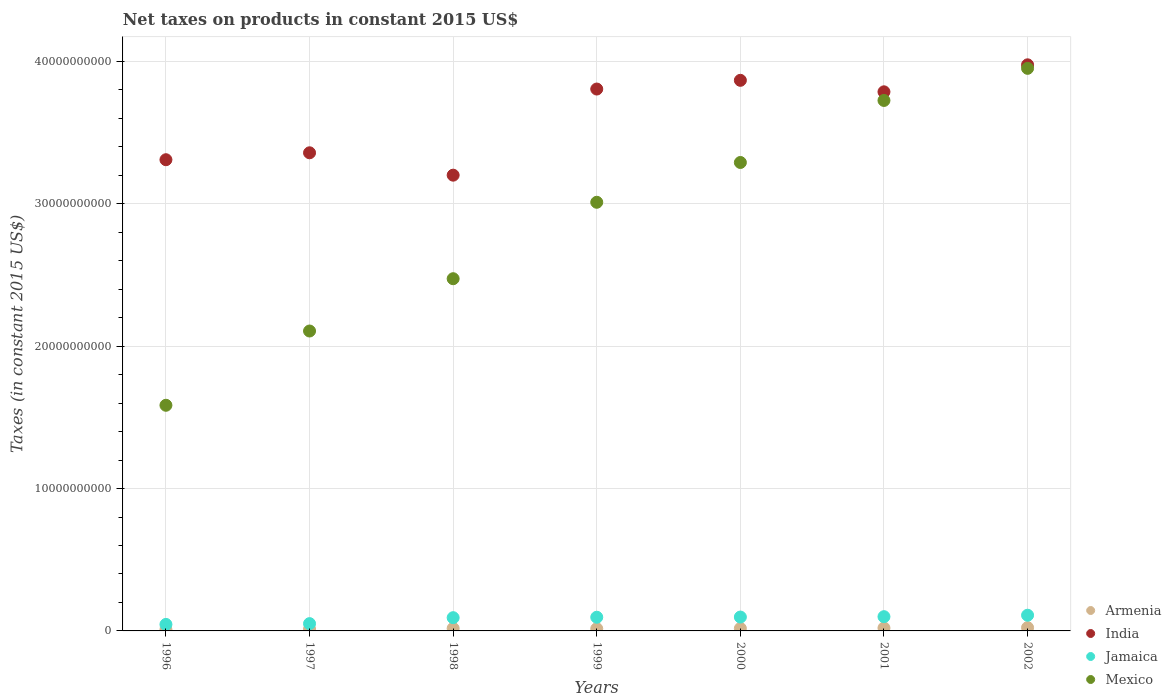What is the net taxes on products in Jamaica in 1998?
Ensure brevity in your answer.  9.30e+08. Across all years, what is the maximum net taxes on products in India?
Ensure brevity in your answer.  3.98e+1. Across all years, what is the minimum net taxes on products in Mexico?
Your response must be concise. 1.58e+1. In which year was the net taxes on products in Armenia maximum?
Provide a short and direct response. 2002. What is the total net taxes on products in Armenia in the graph?
Ensure brevity in your answer.  1.16e+09. What is the difference between the net taxes on products in India in 1997 and that in 1998?
Provide a succinct answer. 1.57e+09. What is the difference between the net taxes on products in Jamaica in 2002 and the net taxes on products in Mexico in 1997?
Make the answer very short. -2.00e+1. What is the average net taxes on products in Mexico per year?
Your response must be concise. 2.88e+1. In the year 2000, what is the difference between the net taxes on products in India and net taxes on products in Mexico?
Offer a very short reply. 5.77e+09. In how many years, is the net taxes on products in Mexico greater than 20000000000 US$?
Provide a short and direct response. 6. What is the ratio of the net taxes on products in Armenia in 1998 to that in 2002?
Make the answer very short. 0.76. Is the net taxes on products in India in 1997 less than that in 1998?
Offer a very short reply. No. Is the difference between the net taxes on products in India in 1999 and 2002 greater than the difference between the net taxes on products in Mexico in 1999 and 2002?
Offer a very short reply. Yes. What is the difference between the highest and the second highest net taxes on products in Armenia?
Ensure brevity in your answer.  2.52e+07. What is the difference between the highest and the lowest net taxes on products in Mexico?
Give a very brief answer. 2.37e+1. In how many years, is the net taxes on products in Jamaica greater than the average net taxes on products in Jamaica taken over all years?
Ensure brevity in your answer.  5. Is the sum of the net taxes on products in Jamaica in 1996 and 2002 greater than the maximum net taxes on products in Armenia across all years?
Your answer should be very brief. Yes. Is it the case that in every year, the sum of the net taxes on products in Jamaica and net taxes on products in Armenia  is greater than the sum of net taxes on products in India and net taxes on products in Mexico?
Your response must be concise. No. Does the net taxes on products in Mexico monotonically increase over the years?
Offer a very short reply. Yes. Is the net taxes on products in Jamaica strictly greater than the net taxes on products in Mexico over the years?
Your answer should be very brief. No. How many dotlines are there?
Offer a very short reply. 4. What is the difference between two consecutive major ticks on the Y-axis?
Make the answer very short. 1.00e+1. Are the values on the major ticks of Y-axis written in scientific E-notation?
Make the answer very short. No. Does the graph contain any zero values?
Your response must be concise. No. Does the graph contain grids?
Keep it short and to the point. Yes. Where does the legend appear in the graph?
Provide a short and direct response. Bottom right. How are the legend labels stacked?
Offer a terse response. Vertical. What is the title of the graph?
Provide a succinct answer. Net taxes on products in constant 2015 US$. Does "Bulgaria" appear as one of the legend labels in the graph?
Offer a very short reply. No. What is the label or title of the X-axis?
Ensure brevity in your answer.  Years. What is the label or title of the Y-axis?
Make the answer very short. Taxes (in constant 2015 US$). What is the Taxes (in constant 2015 US$) in Armenia in 1996?
Provide a short and direct response. 8.81e+07. What is the Taxes (in constant 2015 US$) in India in 1996?
Your response must be concise. 3.31e+1. What is the Taxes (in constant 2015 US$) of Jamaica in 1996?
Your response must be concise. 4.57e+08. What is the Taxes (in constant 2015 US$) of Mexico in 1996?
Your answer should be compact. 1.58e+1. What is the Taxes (in constant 2015 US$) in Armenia in 1997?
Ensure brevity in your answer.  1.31e+08. What is the Taxes (in constant 2015 US$) of India in 1997?
Ensure brevity in your answer.  3.36e+1. What is the Taxes (in constant 2015 US$) in Jamaica in 1997?
Offer a terse response. 5.12e+08. What is the Taxes (in constant 2015 US$) in Mexico in 1997?
Offer a terse response. 2.11e+1. What is the Taxes (in constant 2015 US$) of Armenia in 1998?
Your answer should be compact. 1.75e+08. What is the Taxes (in constant 2015 US$) in India in 1998?
Provide a short and direct response. 3.20e+1. What is the Taxes (in constant 2015 US$) in Jamaica in 1998?
Keep it short and to the point. 9.30e+08. What is the Taxes (in constant 2015 US$) in Mexico in 1998?
Keep it short and to the point. 2.47e+1. What is the Taxes (in constant 2015 US$) in Armenia in 1999?
Your answer should be very brief. 1.57e+08. What is the Taxes (in constant 2015 US$) of India in 1999?
Ensure brevity in your answer.  3.81e+1. What is the Taxes (in constant 2015 US$) of Jamaica in 1999?
Offer a very short reply. 9.61e+08. What is the Taxes (in constant 2015 US$) of Mexico in 1999?
Give a very brief answer. 3.01e+1. What is the Taxes (in constant 2015 US$) in Armenia in 2000?
Your response must be concise. 1.75e+08. What is the Taxes (in constant 2015 US$) in India in 2000?
Offer a very short reply. 3.87e+1. What is the Taxes (in constant 2015 US$) in Jamaica in 2000?
Provide a short and direct response. 9.74e+08. What is the Taxes (in constant 2015 US$) of Mexico in 2000?
Provide a succinct answer. 3.29e+1. What is the Taxes (in constant 2015 US$) in Armenia in 2001?
Your answer should be compact. 2.05e+08. What is the Taxes (in constant 2015 US$) in India in 2001?
Keep it short and to the point. 3.79e+1. What is the Taxes (in constant 2015 US$) of Jamaica in 2001?
Provide a succinct answer. 1.00e+09. What is the Taxes (in constant 2015 US$) in Mexico in 2001?
Keep it short and to the point. 3.73e+1. What is the Taxes (in constant 2015 US$) of Armenia in 2002?
Offer a terse response. 2.30e+08. What is the Taxes (in constant 2015 US$) in India in 2002?
Your answer should be compact. 3.98e+1. What is the Taxes (in constant 2015 US$) of Jamaica in 2002?
Your answer should be compact. 1.10e+09. What is the Taxes (in constant 2015 US$) of Mexico in 2002?
Provide a short and direct response. 3.95e+1. Across all years, what is the maximum Taxes (in constant 2015 US$) of Armenia?
Give a very brief answer. 2.30e+08. Across all years, what is the maximum Taxes (in constant 2015 US$) in India?
Your answer should be compact. 3.98e+1. Across all years, what is the maximum Taxes (in constant 2015 US$) of Jamaica?
Offer a very short reply. 1.10e+09. Across all years, what is the maximum Taxes (in constant 2015 US$) in Mexico?
Offer a terse response. 3.95e+1. Across all years, what is the minimum Taxes (in constant 2015 US$) of Armenia?
Give a very brief answer. 8.81e+07. Across all years, what is the minimum Taxes (in constant 2015 US$) in India?
Give a very brief answer. 3.20e+1. Across all years, what is the minimum Taxes (in constant 2015 US$) of Jamaica?
Ensure brevity in your answer.  4.57e+08. Across all years, what is the minimum Taxes (in constant 2015 US$) in Mexico?
Provide a succinct answer. 1.58e+1. What is the total Taxes (in constant 2015 US$) in Armenia in the graph?
Your answer should be very brief. 1.16e+09. What is the total Taxes (in constant 2015 US$) of India in the graph?
Your answer should be very brief. 2.53e+11. What is the total Taxes (in constant 2015 US$) of Jamaica in the graph?
Provide a short and direct response. 5.94e+09. What is the total Taxes (in constant 2015 US$) in Mexico in the graph?
Your response must be concise. 2.01e+11. What is the difference between the Taxes (in constant 2015 US$) in Armenia in 1996 and that in 1997?
Provide a succinct answer. -4.30e+07. What is the difference between the Taxes (in constant 2015 US$) of India in 1996 and that in 1997?
Offer a very short reply. -4.86e+08. What is the difference between the Taxes (in constant 2015 US$) in Jamaica in 1996 and that in 1997?
Provide a short and direct response. -5.55e+07. What is the difference between the Taxes (in constant 2015 US$) of Mexico in 1996 and that in 1997?
Give a very brief answer. -5.22e+09. What is the difference between the Taxes (in constant 2015 US$) of Armenia in 1996 and that in 1998?
Your answer should be compact. -8.73e+07. What is the difference between the Taxes (in constant 2015 US$) of India in 1996 and that in 1998?
Your answer should be compact. 1.09e+09. What is the difference between the Taxes (in constant 2015 US$) of Jamaica in 1996 and that in 1998?
Make the answer very short. -4.73e+08. What is the difference between the Taxes (in constant 2015 US$) of Mexico in 1996 and that in 1998?
Your response must be concise. -8.89e+09. What is the difference between the Taxes (in constant 2015 US$) of Armenia in 1996 and that in 1999?
Your response must be concise. -6.88e+07. What is the difference between the Taxes (in constant 2015 US$) of India in 1996 and that in 1999?
Your answer should be very brief. -4.96e+09. What is the difference between the Taxes (in constant 2015 US$) in Jamaica in 1996 and that in 1999?
Ensure brevity in your answer.  -5.04e+08. What is the difference between the Taxes (in constant 2015 US$) of Mexico in 1996 and that in 1999?
Give a very brief answer. -1.43e+1. What is the difference between the Taxes (in constant 2015 US$) in Armenia in 1996 and that in 2000?
Provide a short and direct response. -8.66e+07. What is the difference between the Taxes (in constant 2015 US$) of India in 1996 and that in 2000?
Your answer should be compact. -5.58e+09. What is the difference between the Taxes (in constant 2015 US$) of Jamaica in 1996 and that in 2000?
Keep it short and to the point. -5.17e+08. What is the difference between the Taxes (in constant 2015 US$) of Mexico in 1996 and that in 2000?
Your response must be concise. -1.71e+1. What is the difference between the Taxes (in constant 2015 US$) in Armenia in 1996 and that in 2001?
Provide a succinct answer. -1.17e+08. What is the difference between the Taxes (in constant 2015 US$) in India in 1996 and that in 2001?
Provide a succinct answer. -4.77e+09. What is the difference between the Taxes (in constant 2015 US$) of Jamaica in 1996 and that in 2001?
Offer a very short reply. -5.44e+08. What is the difference between the Taxes (in constant 2015 US$) of Mexico in 1996 and that in 2001?
Offer a terse response. -2.14e+1. What is the difference between the Taxes (in constant 2015 US$) in Armenia in 1996 and that in 2002?
Keep it short and to the point. -1.42e+08. What is the difference between the Taxes (in constant 2015 US$) in India in 1996 and that in 2002?
Provide a short and direct response. -6.67e+09. What is the difference between the Taxes (in constant 2015 US$) in Jamaica in 1996 and that in 2002?
Your answer should be very brief. -6.46e+08. What is the difference between the Taxes (in constant 2015 US$) in Mexico in 1996 and that in 2002?
Provide a short and direct response. -2.37e+1. What is the difference between the Taxes (in constant 2015 US$) in Armenia in 1997 and that in 1998?
Your answer should be very brief. -4.43e+07. What is the difference between the Taxes (in constant 2015 US$) of India in 1997 and that in 1998?
Make the answer very short. 1.57e+09. What is the difference between the Taxes (in constant 2015 US$) in Jamaica in 1997 and that in 1998?
Make the answer very short. -4.17e+08. What is the difference between the Taxes (in constant 2015 US$) in Mexico in 1997 and that in 1998?
Provide a succinct answer. -3.67e+09. What is the difference between the Taxes (in constant 2015 US$) of Armenia in 1997 and that in 1999?
Your answer should be compact. -2.58e+07. What is the difference between the Taxes (in constant 2015 US$) of India in 1997 and that in 1999?
Ensure brevity in your answer.  -4.48e+09. What is the difference between the Taxes (in constant 2015 US$) in Jamaica in 1997 and that in 1999?
Provide a succinct answer. -4.48e+08. What is the difference between the Taxes (in constant 2015 US$) in Mexico in 1997 and that in 1999?
Your answer should be compact. -9.04e+09. What is the difference between the Taxes (in constant 2015 US$) in Armenia in 1997 and that in 2000?
Your response must be concise. -4.36e+07. What is the difference between the Taxes (in constant 2015 US$) of India in 1997 and that in 2000?
Provide a short and direct response. -5.09e+09. What is the difference between the Taxes (in constant 2015 US$) of Jamaica in 1997 and that in 2000?
Offer a very short reply. -4.62e+08. What is the difference between the Taxes (in constant 2015 US$) in Mexico in 1997 and that in 2000?
Provide a short and direct response. -1.18e+1. What is the difference between the Taxes (in constant 2015 US$) in Armenia in 1997 and that in 2001?
Keep it short and to the point. -7.37e+07. What is the difference between the Taxes (in constant 2015 US$) in India in 1997 and that in 2001?
Keep it short and to the point. -4.28e+09. What is the difference between the Taxes (in constant 2015 US$) in Jamaica in 1997 and that in 2001?
Your response must be concise. -4.88e+08. What is the difference between the Taxes (in constant 2015 US$) in Mexico in 1997 and that in 2001?
Offer a very short reply. -1.62e+1. What is the difference between the Taxes (in constant 2015 US$) of Armenia in 1997 and that in 2002?
Your answer should be very brief. -9.90e+07. What is the difference between the Taxes (in constant 2015 US$) in India in 1997 and that in 2002?
Ensure brevity in your answer.  -6.18e+09. What is the difference between the Taxes (in constant 2015 US$) in Jamaica in 1997 and that in 2002?
Your answer should be compact. -5.90e+08. What is the difference between the Taxes (in constant 2015 US$) of Mexico in 1997 and that in 2002?
Offer a very short reply. -1.84e+1. What is the difference between the Taxes (in constant 2015 US$) in Armenia in 1998 and that in 1999?
Offer a very short reply. 1.85e+07. What is the difference between the Taxes (in constant 2015 US$) of India in 1998 and that in 1999?
Provide a succinct answer. -6.05e+09. What is the difference between the Taxes (in constant 2015 US$) of Jamaica in 1998 and that in 1999?
Provide a succinct answer. -3.12e+07. What is the difference between the Taxes (in constant 2015 US$) of Mexico in 1998 and that in 1999?
Ensure brevity in your answer.  -5.37e+09. What is the difference between the Taxes (in constant 2015 US$) in Armenia in 1998 and that in 2000?
Offer a terse response. 7.20e+05. What is the difference between the Taxes (in constant 2015 US$) in India in 1998 and that in 2000?
Offer a very short reply. -6.66e+09. What is the difference between the Taxes (in constant 2015 US$) of Jamaica in 1998 and that in 2000?
Provide a short and direct response. -4.44e+07. What is the difference between the Taxes (in constant 2015 US$) in Mexico in 1998 and that in 2000?
Make the answer very short. -8.16e+09. What is the difference between the Taxes (in constant 2015 US$) of Armenia in 1998 and that in 2001?
Your answer should be compact. -2.94e+07. What is the difference between the Taxes (in constant 2015 US$) in India in 1998 and that in 2001?
Offer a terse response. -5.85e+09. What is the difference between the Taxes (in constant 2015 US$) of Jamaica in 1998 and that in 2001?
Ensure brevity in your answer.  -7.11e+07. What is the difference between the Taxes (in constant 2015 US$) in Mexico in 1998 and that in 2001?
Your answer should be compact. -1.25e+1. What is the difference between the Taxes (in constant 2015 US$) of Armenia in 1998 and that in 2002?
Offer a terse response. -5.46e+07. What is the difference between the Taxes (in constant 2015 US$) of India in 1998 and that in 2002?
Ensure brevity in your answer.  -7.75e+09. What is the difference between the Taxes (in constant 2015 US$) of Jamaica in 1998 and that in 2002?
Offer a very short reply. -1.73e+08. What is the difference between the Taxes (in constant 2015 US$) in Mexico in 1998 and that in 2002?
Provide a short and direct response. -1.48e+1. What is the difference between the Taxes (in constant 2015 US$) of Armenia in 1999 and that in 2000?
Keep it short and to the point. -1.78e+07. What is the difference between the Taxes (in constant 2015 US$) of India in 1999 and that in 2000?
Provide a short and direct response. -6.12e+08. What is the difference between the Taxes (in constant 2015 US$) of Jamaica in 1999 and that in 2000?
Give a very brief answer. -1.32e+07. What is the difference between the Taxes (in constant 2015 US$) in Mexico in 1999 and that in 2000?
Provide a short and direct response. -2.80e+09. What is the difference between the Taxes (in constant 2015 US$) in Armenia in 1999 and that in 2001?
Provide a short and direct response. -4.79e+07. What is the difference between the Taxes (in constant 2015 US$) in India in 1999 and that in 2001?
Keep it short and to the point. 1.95e+08. What is the difference between the Taxes (in constant 2015 US$) in Jamaica in 1999 and that in 2001?
Provide a short and direct response. -3.99e+07. What is the difference between the Taxes (in constant 2015 US$) of Mexico in 1999 and that in 2001?
Your answer should be very brief. -7.15e+09. What is the difference between the Taxes (in constant 2015 US$) in Armenia in 1999 and that in 2002?
Your response must be concise. -7.31e+07. What is the difference between the Taxes (in constant 2015 US$) in India in 1999 and that in 2002?
Ensure brevity in your answer.  -1.70e+09. What is the difference between the Taxes (in constant 2015 US$) of Jamaica in 1999 and that in 2002?
Offer a terse response. -1.42e+08. What is the difference between the Taxes (in constant 2015 US$) in Mexico in 1999 and that in 2002?
Offer a very short reply. -9.41e+09. What is the difference between the Taxes (in constant 2015 US$) of Armenia in 2000 and that in 2001?
Offer a terse response. -3.01e+07. What is the difference between the Taxes (in constant 2015 US$) of India in 2000 and that in 2001?
Your answer should be very brief. 8.07e+08. What is the difference between the Taxes (in constant 2015 US$) of Jamaica in 2000 and that in 2001?
Provide a succinct answer. -2.67e+07. What is the difference between the Taxes (in constant 2015 US$) in Mexico in 2000 and that in 2001?
Make the answer very short. -4.36e+09. What is the difference between the Taxes (in constant 2015 US$) in Armenia in 2000 and that in 2002?
Your response must be concise. -5.53e+07. What is the difference between the Taxes (in constant 2015 US$) of India in 2000 and that in 2002?
Your answer should be very brief. -1.09e+09. What is the difference between the Taxes (in constant 2015 US$) of Jamaica in 2000 and that in 2002?
Your response must be concise. -1.28e+08. What is the difference between the Taxes (in constant 2015 US$) of Mexico in 2000 and that in 2002?
Keep it short and to the point. -6.61e+09. What is the difference between the Taxes (in constant 2015 US$) in Armenia in 2001 and that in 2002?
Your answer should be very brief. -2.52e+07. What is the difference between the Taxes (in constant 2015 US$) of India in 2001 and that in 2002?
Give a very brief answer. -1.90e+09. What is the difference between the Taxes (in constant 2015 US$) in Jamaica in 2001 and that in 2002?
Provide a succinct answer. -1.02e+08. What is the difference between the Taxes (in constant 2015 US$) of Mexico in 2001 and that in 2002?
Offer a terse response. -2.26e+09. What is the difference between the Taxes (in constant 2015 US$) of Armenia in 1996 and the Taxes (in constant 2015 US$) of India in 1997?
Offer a very short reply. -3.35e+1. What is the difference between the Taxes (in constant 2015 US$) of Armenia in 1996 and the Taxes (in constant 2015 US$) of Jamaica in 1997?
Your answer should be very brief. -4.24e+08. What is the difference between the Taxes (in constant 2015 US$) in Armenia in 1996 and the Taxes (in constant 2015 US$) in Mexico in 1997?
Your answer should be very brief. -2.10e+1. What is the difference between the Taxes (in constant 2015 US$) in India in 1996 and the Taxes (in constant 2015 US$) in Jamaica in 1997?
Offer a terse response. 3.26e+1. What is the difference between the Taxes (in constant 2015 US$) in India in 1996 and the Taxes (in constant 2015 US$) in Mexico in 1997?
Ensure brevity in your answer.  1.20e+1. What is the difference between the Taxes (in constant 2015 US$) in Jamaica in 1996 and the Taxes (in constant 2015 US$) in Mexico in 1997?
Your answer should be very brief. -2.06e+1. What is the difference between the Taxes (in constant 2015 US$) in Armenia in 1996 and the Taxes (in constant 2015 US$) in India in 1998?
Offer a very short reply. -3.19e+1. What is the difference between the Taxes (in constant 2015 US$) in Armenia in 1996 and the Taxes (in constant 2015 US$) in Jamaica in 1998?
Give a very brief answer. -8.42e+08. What is the difference between the Taxes (in constant 2015 US$) in Armenia in 1996 and the Taxes (in constant 2015 US$) in Mexico in 1998?
Offer a terse response. -2.46e+1. What is the difference between the Taxes (in constant 2015 US$) in India in 1996 and the Taxes (in constant 2015 US$) in Jamaica in 1998?
Provide a short and direct response. 3.22e+1. What is the difference between the Taxes (in constant 2015 US$) in India in 1996 and the Taxes (in constant 2015 US$) in Mexico in 1998?
Provide a short and direct response. 8.36e+09. What is the difference between the Taxes (in constant 2015 US$) of Jamaica in 1996 and the Taxes (in constant 2015 US$) of Mexico in 1998?
Your answer should be very brief. -2.43e+1. What is the difference between the Taxes (in constant 2015 US$) in Armenia in 1996 and the Taxes (in constant 2015 US$) in India in 1999?
Your answer should be compact. -3.80e+1. What is the difference between the Taxes (in constant 2015 US$) in Armenia in 1996 and the Taxes (in constant 2015 US$) in Jamaica in 1999?
Give a very brief answer. -8.73e+08. What is the difference between the Taxes (in constant 2015 US$) of Armenia in 1996 and the Taxes (in constant 2015 US$) of Mexico in 1999?
Offer a very short reply. -3.00e+1. What is the difference between the Taxes (in constant 2015 US$) in India in 1996 and the Taxes (in constant 2015 US$) in Jamaica in 1999?
Ensure brevity in your answer.  3.21e+1. What is the difference between the Taxes (in constant 2015 US$) of India in 1996 and the Taxes (in constant 2015 US$) of Mexico in 1999?
Your answer should be compact. 2.99e+09. What is the difference between the Taxes (in constant 2015 US$) in Jamaica in 1996 and the Taxes (in constant 2015 US$) in Mexico in 1999?
Your response must be concise. -2.96e+1. What is the difference between the Taxes (in constant 2015 US$) of Armenia in 1996 and the Taxes (in constant 2015 US$) of India in 2000?
Provide a short and direct response. -3.86e+1. What is the difference between the Taxes (in constant 2015 US$) in Armenia in 1996 and the Taxes (in constant 2015 US$) in Jamaica in 2000?
Your answer should be very brief. -8.86e+08. What is the difference between the Taxes (in constant 2015 US$) of Armenia in 1996 and the Taxes (in constant 2015 US$) of Mexico in 2000?
Your answer should be compact. -3.28e+1. What is the difference between the Taxes (in constant 2015 US$) in India in 1996 and the Taxes (in constant 2015 US$) in Jamaica in 2000?
Ensure brevity in your answer.  3.21e+1. What is the difference between the Taxes (in constant 2015 US$) of India in 1996 and the Taxes (in constant 2015 US$) of Mexico in 2000?
Your answer should be compact. 1.94e+08. What is the difference between the Taxes (in constant 2015 US$) in Jamaica in 1996 and the Taxes (in constant 2015 US$) in Mexico in 2000?
Give a very brief answer. -3.24e+1. What is the difference between the Taxes (in constant 2015 US$) in Armenia in 1996 and the Taxes (in constant 2015 US$) in India in 2001?
Provide a succinct answer. -3.78e+1. What is the difference between the Taxes (in constant 2015 US$) of Armenia in 1996 and the Taxes (in constant 2015 US$) of Jamaica in 2001?
Keep it short and to the point. -9.13e+08. What is the difference between the Taxes (in constant 2015 US$) in Armenia in 1996 and the Taxes (in constant 2015 US$) in Mexico in 2001?
Give a very brief answer. -3.72e+1. What is the difference between the Taxes (in constant 2015 US$) in India in 1996 and the Taxes (in constant 2015 US$) in Jamaica in 2001?
Provide a succinct answer. 3.21e+1. What is the difference between the Taxes (in constant 2015 US$) in India in 1996 and the Taxes (in constant 2015 US$) in Mexico in 2001?
Give a very brief answer. -4.16e+09. What is the difference between the Taxes (in constant 2015 US$) in Jamaica in 1996 and the Taxes (in constant 2015 US$) in Mexico in 2001?
Ensure brevity in your answer.  -3.68e+1. What is the difference between the Taxes (in constant 2015 US$) of Armenia in 1996 and the Taxes (in constant 2015 US$) of India in 2002?
Offer a terse response. -3.97e+1. What is the difference between the Taxes (in constant 2015 US$) in Armenia in 1996 and the Taxes (in constant 2015 US$) in Jamaica in 2002?
Ensure brevity in your answer.  -1.01e+09. What is the difference between the Taxes (in constant 2015 US$) in Armenia in 1996 and the Taxes (in constant 2015 US$) in Mexico in 2002?
Offer a very short reply. -3.94e+1. What is the difference between the Taxes (in constant 2015 US$) in India in 1996 and the Taxes (in constant 2015 US$) in Jamaica in 2002?
Offer a terse response. 3.20e+1. What is the difference between the Taxes (in constant 2015 US$) in India in 1996 and the Taxes (in constant 2015 US$) in Mexico in 2002?
Your answer should be compact. -6.42e+09. What is the difference between the Taxes (in constant 2015 US$) in Jamaica in 1996 and the Taxes (in constant 2015 US$) in Mexico in 2002?
Offer a terse response. -3.91e+1. What is the difference between the Taxes (in constant 2015 US$) in Armenia in 1997 and the Taxes (in constant 2015 US$) in India in 1998?
Make the answer very short. -3.19e+1. What is the difference between the Taxes (in constant 2015 US$) of Armenia in 1997 and the Taxes (in constant 2015 US$) of Jamaica in 1998?
Provide a short and direct response. -7.99e+08. What is the difference between the Taxes (in constant 2015 US$) in Armenia in 1997 and the Taxes (in constant 2015 US$) in Mexico in 1998?
Provide a succinct answer. -2.46e+1. What is the difference between the Taxes (in constant 2015 US$) in India in 1997 and the Taxes (in constant 2015 US$) in Jamaica in 1998?
Make the answer very short. 3.27e+1. What is the difference between the Taxes (in constant 2015 US$) in India in 1997 and the Taxes (in constant 2015 US$) in Mexico in 1998?
Offer a very short reply. 8.84e+09. What is the difference between the Taxes (in constant 2015 US$) in Jamaica in 1997 and the Taxes (in constant 2015 US$) in Mexico in 1998?
Provide a succinct answer. -2.42e+1. What is the difference between the Taxes (in constant 2015 US$) in Armenia in 1997 and the Taxes (in constant 2015 US$) in India in 1999?
Your answer should be very brief. -3.79e+1. What is the difference between the Taxes (in constant 2015 US$) in Armenia in 1997 and the Taxes (in constant 2015 US$) in Jamaica in 1999?
Offer a very short reply. -8.30e+08. What is the difference between the Taxes (in constant 2015 US$) of Armenia in 1997 and the Taxes (in constant 2015 US$) of Mexico in 1999?
Give a very brief answer. -3.00e+1. What is the difference between the Taxes (in constant 2015 US$) of India in 1997 and the Taxes (in constant 2015 US$) of Jamaica in 1999?
Provide a succinct answer. 3.26e+1. What is the difference between the Taxes (in constant 2015 US$) of India in 1997 and the Taxes (in constant 2015 US$) of Mexico in 1999?
Ensure brevity in your answer.  3.48e+09. What is the difference between the Taxes (in constant 2015 US$) in Jamaica in 1997 and the Taxes (in constant 2015 US$) in Mexico in 1999?
Ensure brevity in your answer.  -2.96e+1. What is the difference between the Taxes (in constant 2015 US$) in Armenia in 1997 and the Taxes (in constant 2015 US$) in India in 2000?
Offer a terse response. -3.85e+1. What is the difference between the Taxes (in constant 2015 US$) in Armenia in 1997 and the Taxes (in constant 2015 US$) in Jamaica in 2000?
Provide a succinct answer. -8.43e+08. What is the difference between the Taxes (in constant 2015 US$) of Armenia in 1997 and the Taxes (in constant 2015 US$) of Mexico in 2000?
Keep it short and to the point. -3.28e+1. What is the difference between the Taxes (in constant 2015 US$) in India in 1997 and the Taxes (in constant 2015 US$) in Jamaica in 2000?
Offer a terse response. 3.26e+1. What is the difference between the Taxes (in constant 2015 US$) of India in 1997 and the Taxes (in constant 2015 US$) of Mexico in 2000?
Your answer should be very brief. 6.80e+08. What is the difference between the Taxes (in constant 2015 US$) of Jamaica in 1997 and the Taxes (in constant 2015 US$) of Mexico in 2000?
Provide a short and direct response. -3.24e+1. What is the difference between the Taxes (in constant 2015 US$) of Armenia in 1997 and the Taxes (in constant 2015 US$) of India in 2001?
Provide a short and direct response. -3.77e+1. What is the difference between the Taxes (in constant 2015 US$) of Armenia in 1997 and the Taxes (in constant 2015 US$) of Jamaica in 2001?
Your answer should be compact. -8.70e+08. What is the difference between the Taxes (in constant 2015 US$) in Armenia in 1997 and the Taxes (in constant 2015 US$) in Mexico in 2001?
Offer a terse response. -3.71e+1. What is the difference between the Taxes (in constant 2015 US$) of India in 1997 and the Taxes (in constant 2015 US$) of Jamaica in 2001?
Provide a short and direct response. 3.26e+1. What is the difference between the Taxes (in constant 2015 US$) in India in 1997 and the Taxes (in constant 2015 US$) in Mexico in 2001?
Your answer should be compact. -3.68e+09. What is the difference between the Taxes (in constant 2015 US$) of Jamaica in 1997 and the Taxes (in constant 2015 US$) of Mexico in 2001?
Give a very brief answer. -3.67e+1. What is the difference between the Taxes (in constant 2015 US$) of Armenia in 1997 and the Taxes (in constant 2015 US$) of India in 2002?
Provide a short and direct response. -3.96e+1. What is the difference between the Taxes (in constant 2015 US$) in Armenia in 1997 and the Taxes (in constant 2015 US$) in Jamaica in 2002?
Your answer should be very brief. -9.72e+08. What is the difference between the Taxes (in constant 2015 US$) of Armenia in 1997 and the Taxes (in constant 2015 US$) of Mexico in 2002?
Ensure brevity in your answer.  -3.94e+1. What is the difference between the Taxes (in constant 2015 US$) in India in 1997 and the Taxes (in constant 2015 US$) in Jamaica in 2002?
Provide a succinct answer. 3.25e+1. What is the difference between the Taxes (in constant 2015 US$) of India in 1997 and the Taxes (in constant 2015 US$) of Mexico in 2002?
Your answer should be very brief. -5.93e+09. What is the difference between the Taxes (in constant 2015 US$) of Jamaica in 1997 and the Taxes (in constant 2015 US$) of Mexico in 2002?
Offer a terse response. -3.90e+1. What is the difference between the Taxes (in constant 2015 US$) of Armenia in 1998 and the Taxes (in constant 2015 US$) of India in 1999?
Offer a terse response. -3.79e+1. What is the difference between the Taxes (in constant 2015 US$) in Armenia in 1998 and the Taxes (in constant 2015 US$) in Jamaica in 1999?
Ensure brevity in your answer.  -7.86e+08. What is the difference between the Taxes (in constant 2015 US$) in Armenia in 1998 and the Taxes (in constant 2015 US$) in Mexico in 1999?
Provide a succinct answer. -2.99e+1. What is the difference between the Taxes (in constant 2015 US$) of India in 1998 and the Taxes (in constant 2015 US$) of Jamaica in 1999?
Your answer should be very brief. 3.10e+1. What is the difference between the Taxes (in constant 2015 US$) in India in 1998 and the Taxes (in constant 2015 US$) in Mexico in 1999?
Keep it short and to the point. 1.90e+09. What is the difference between the Taxes (in constant 2015 US$) of Jamaica in 1998 and the Taxes (in constant 2015 US$) of Mexico in 1999?
Your response must be concise. -2.92e+1. What is the difference between the Taxes (in constant 2015 US$) of Armenia in 1998 and the Taxes (in constant 2015 US$) of India in 2000?
Your response must be concise. -3.85e+1. What is the difference between the Taxes (in constant 2015 US$) of Armenia in 1998 and the Taxes (in constant 2015 US$) of Jamaica in 2000?
Keep it short and to the point. -7.99e+08. What is the difference between the Taxes (in constant 2015 US$) of Armenia in 1998 and the Taxes (in constant 2015 US$) of Mexico in 2000?
Make the answer very short. -3.27e+1. What is the difference between the Taxes (in constant 2015 US$) in India in 1998 and the Taxes (in constant 2015 US$) in Jamaica in 2000?
Offer a very short reply. 3.10e+1. What is the difference between the Taxes (in constant 2015 US$) in India in 1998 and the Taxes (in constant 2015 US$) in Mexico in 2000?
Offer a very short reply. -8.91e+08. What is the difference between the Taxes (in constant 2015 US$) in Jamaica in 1998 and the Taxes (in constant 2015 US$) in Mexico in 2000?
Provide a short and direct response. -3.20e+1. What is the difference between the Taxes (in constant 2015 US$) in Armenia in 1998 and the Taxes (in constant 2015 US$) in India in 2001?
Offer a terse response. -3.77e+1. What is the difference between the Taxes (in constant 2015 US$) of Armenia in 1998 and the Taxes (in constant 2015 US$) of Jamaica in 2001?
Provide a short and direct response. -8.25e+08. What is the difference between the Taxes (in constant 2015 US$) of Armenia in 1998 and the Taxes (in constant 2015 US$) of Mexico in 2001?
Offer a very short reply. -3.71e+1. What is the difference between the Taxes (in constant 2015 US$) of India in 1998 and the Taxes (in constant 2015 US$) of Jamaica in 2001?
Offer a very short reply. 3.10e+1. What is the difference between the Taxes (in constant 2015 US$) in India in 1998 and the Taxes (in constant 2015 US$) in Mexico in 2001?
Keep it short and to the point. -5.25e+09. What is the difference between the Taxes (in constant 2015 US$) in Jamaica in 1998 and the Taxes (in constant 2015 US$) in Mexico in 2001?
Provide a short and direct response. -3.63e+1. What is the difference between the Taxes (in constant 2015 US$) of Armenia in 1998 and the Taxes (in constant 2015 US$) of India in 2002?
Ensure brevity in your answer.  -3.96e+1. What is the difference between the Taxes (in constant 2015 US$) of Armenia in 1998 and the Taxes (in constant 2015 US$) of Jamaica in 2002?
Give a very brief answer. -9.27e+08. What is the difference between the Taxes (in constant 2015 US$) of Armenia in 1998 and the Taxes (in constant 2015 US$) of Mexico in 2002?
Keep it short and to the point. -3.93e+1. What is the difference between the Taxes (in constant 2015 US$) of India in 1998 and the Taxes (in constant 2015 US$) of Jamaica in 2002?
Offer a very short reply. 3.09e+1. What is the difference between the Taxes (in constant 2015 US$) of India in 1998 and the Taxes (in constant 2015 US$) of Mexico in 2002?
Offer a terse response. -7.50e+09. What is the difference between the Taxes (in constant 2015 US$) of Jamaica in 1998 and the Taxes (in constant 2015 US$) of Mexico in 2002?
Give a very brief answer. -3.86e+1. What is the difference between the Taxes (in constant 2015 US$) in Armenia in 1999 and the Taxes (in constant 2015 US$) in India in 2000?
Ensure brevity in your answer.  -3.85e+1. What is the difference between the Taxes (in constant 2015 US$) of Armenia in 1999 and the Taxes (in constant 2015 US$) of Jamaica in 2000?
Offer a very short reply. -8.17e+08. What is the difference between the Taxes (in constant 2015 US$) of Armenia in 1999 and the Taxes (in constant 2015 US$) of Mexico in 2000?
Your answer should be very brief. -3.27e+1. What is the difference between the Taxes (in constant 2015 US$) in India in 1999 and the Taxes (in constant 2015 US$) in Jamaica in 2000?
Keep it short and to the point. 3.71e+1. What is the difference between the Taxes (in constant 2015 US$) of India in 1999 and the Taxes (in constant 2015 US$) of Mexico in 2000?
Ensure brevity in your answer.  5.16e+09. What is the difference between the Taxes (in constant 2015 US$) in Jamaica in 1999 and the Taxes (in constant 2015 US$) in Mexico in 2000?
Ensure brevity in your answer.  -3.19e+1. What is the difference between the Taxes (in constant 2015 US$) of Armenia in 1999 and the Taxes (in constant 2015 US$) of India in 2001?
Provide a succinct answer. -3.77e+1. What is the difference between the Taxes (in constant 2015 US$) of Armenia in 1999 and the Taxes (in constant 2015 US$) of Jamaica in 2001?
Give a very brief answer. -8.44e+08. What is the difference between the Taxes (in constant 2015 US$) in Armenia in 1999 and the Taxes (in constant 2015 US$) in Mexico in 2001?
Your answer should be compact. -3.71e+1. What is the difference between the Taxes (in constant 2015 US$) of India in 1999 and the Taxes (in constant 2015 US$) of Jamaica in 2001?
Ensure brevity in your answer.  3.71e+1. What is the difference between the Taxes (in constant 2015 US$) in India in 1999 and the Taxes (in constant 2015 US$) in Mexico in 2001?
Keep it short and to the point. 8.01e+08. What is the difference between the Taxes (in constant 2015 US$) of Jamaica in 1999 and the Taxes (in constant 2015 US$) of Mexico in 2001?
Keep it short and to the point. -3.63e+1. What is the difference between the Taxes (in constant 2015 US$) of Armenia in 1999 and the Taxes (in constant 2015 US$) of India in 2002?
Ensure brevity in your answer.  -3.96e+1. What is the difference between the Taxes (in constant 2015 US$) in Armenia in 1999 and the Taxes (in constant 2015 US$) in Jamaica in 2002?
Give a very brief answer. -9.46e+08. What is the difference between the Taxes (in constant 2015 US$) in Armenia in 1999 and the Taxes (in constant 2015 US$) in Mexico in 2002?
Give a very brief answer. -3.94e+1. What is the difference between the Taxes (in constant 2015 US$) in India in 1999 and the Taxes (in constant 2015 US$) in Jamaica in 2002?
Ensure brevity in your answer.  3.70e+1. What is the difference between the Taxes (in constant 2015 US$) of India in 1999 and the Taxes (in constant 2015 US$) of Mexico in 2002?
Offer a terse response. -1.45e+09. What is the difference between the Taxes (in constant 2015 US$) in Jamaica in 1999 and the Taxes (in constant 2015 US$) in Mexico in 2002?
Give a very brief answer. -3.86e+1. What is the difference between the Taxes (in constant 2015 US$) of Armenia in 2000 and the Taxes (in constant 2015 US$) of India in 2001?
Make the answer very short. -3.77e+1. What is the difference between the Taxes (in constant 2015 US$) of Armenia in 2000 and the Taxes (in constant 2015 US$) of Jamaica in 2001?
Provide a succinct answer. -8.26e+08. What is the difference between the Taxes (in constant 2015 US$) in Armenia in 2000 and the Taxes (in constant 2015 US$) in Mexico in 2001?
Give a very brief answer. -3.71e+1. What is the difference between the Taxes (in constant 2015 US$) of India in 2000 and the Taxes (in constant 2015 US$) of Jamaica in 2001?
Give a very brief answer. 3.77e+1. What is the difference between the Taxes (in constant 2015 US$) of India in 2000 and the Taxes (in constant 2015 US$) of Mexico in 2001?
Provide a succinct answer. 1.41e+09. What is the difference between the Taxes (in constant 2015 US$) of Jamaica in 2000 and the Taxes (in constant 2015 US$) of Mexico in 2001?
Make the answer very short. -3.63e+1. What is the difference between the Taxes (in constant 2015 US$) in Armenia in 2000 and the Taxes (in constant 2015 US$) in India in 2002?
Your answer should be compact. -3.96e+1. What is the difference between the Taxes (in constant 2015 US$) in Armenia in 2000 and the Taxes (in constant 2015 US$) in Jamaica in 2002?
Offer a very short reply. -9.28e+08. What is the difference between the Taxes (in constant 2015 US$) of Armenia in 2000 and the Taxes (in constant 2015 US$) of Mexico in 2002?
Provide a succinct answer. -3.93e+1. What is the difference between the Taxes (in constant 2015 US$) of India in 2000 and the Taxes (in constant 2015 US$) of Jamaica in 2002?
Keep it short and to the point. 3.76e+1. What is the difference between the Taxes (in constant 2015 US$) in India in 2000 and the Taxes (in constant 2015 US$) in Mexico in 2002?
Offer a very short reply. -8.42e+08. What is the difference between the Taxes (in constant 2015 US$) in Jamaica in 2000 and the Taxes (in constant 2015 US$) in Mexico in 2002?
Offer a terse response. -3.85e+1. What is the difference between the Taxes (in constant 2015 US$) of Armenia in 2001 and the Taxes (in constant 2015 US$) of India in 2002?
Offer a terse response. -3.96e+1. What is the difference between the Taxes (in constant 2015 US$) of Armenia in 2001 and the Taxes (in constant 2015 US$) of Jamaica in 2002?
Offer a terse response. -8.98e+08. What is the difference between the Taxes (in constant 2015 US$) of Armenia in 2001 and the Taxes (in constant 2015 US$) of Mexico in 2002?
Ensure brevity in your answer.  -3.93e+1. What is the difference between the Taxes (in constant 2015 US$) in India in 2001 and the Taxes (in constant 2015 US$) in Jamaica in 2002?
Offer a very short reply. 3.68e+1. What is the difference between the Taxes (in constant 2015 US$) of India in 2001 and the Taxes (in constant 2015 US$) of Mexico in 2002?
Keep it short and to the point. -1.65e+09. What is the difference between the Taxes (in constant 2015 US$) of Jamaica in 2001 and the Taxes (in constant 2015 US$) of Mexico in 2002?
Keep it short and to the point. -3.85e+1. What is the average Taxes (in constant 2015 US$) of Armenia per year?
Offer a very short reply. 1.66e+08. What is the average Taxes (in constant 2015 US$) of India per year?
Your response must be concise. 3.61e+1. What is the average Taxes (in constant 2015 US$) of Jamaica per year?
Your answer should be compact. 8.48e+08. What is the average Taxes (in constant 2015 US$) of Mexico per year?
Offer a terse response. 2.88e+1. In the year 1996, what is the difference between the Taxes (in constant 2015 US$) in Armenia and Taxes (in constant 2015 US$) in India?
Keep it short and to the point. -3.30e+1. In the year 1996, what is the difference between the Taxes (in constant 2015 US$) in Armenia and Taxes (in constant 2015 US$) in Jamaica?
Keep it short and to the point. -3.69e+08. In the year 1996, what is the difference between the Taxes (in constant 2015 US$) of Armenia and Taxes (in constant 2015 US$) of Mexico?
Make the answer very short. -1.58e+1. In the year 1996, what is the difference between the Taxes (in constant 2015 US$) of India and Taxes (in constant 2015 US$) of Jamaica?
Your response must be concise. 3.26e+1. In the year 1996, what is the difference between the Taxes (in constant 2015 US$) of India and Taxes (in constant 2015 US$) of Mexico?
Give a very brief answer. 1.72e+1. In the year 1996, what is the difference between the Taxes (in constant 2015 US$) in Jamaica and Taxes (in constant 2015 US$) in Mexico?
Your response must be concise. -1.54e+1. In the year 1997, what is the difference between the Taxes (in constant 2015 US$) of Armenia and Taxes (in constant 2015 US$) of India?
Make the answer very short. -3.34e+1. In the year 1997, what is the difference between the Taxes (in constant 2015 US$) in Armenia and Taxes (in constant 2015 US$) in Jamaica?
Your response must be concise. -3.81e+08. In the year 1997, what is the difference between the Taxes (in constant 2015 US$) in Armenia and Taxes (in constant 2015 US$) in Mexico?
Provide a succinct answer. -2.09e+1. In the year 1997, what is the difference between the Taxes (in constant 2015 US$) of India and Taxes (in constant 2015 US$) of Jamaica?
Provide a short and direct response. 3.31e+1. In the year 1997, what is the difference between the Taxes (in constant 2015 US$) in India and Taxes (in constant 2015 US$) in Mexico?
Provide a succinct answer. 1.25e+1. In the year 1997, what is the difference between the Taxes (in constant 2015 US$) in Jamaica and Taxes (in constant 2015 US$) in Mexico?
Your answer should be compact. -2.06e+1. In the year 1998, what is the difference between the Taxes (in constant 2015 US$) in Armenia and Taxes (in constant 2015 US$) in India?
Offer a very short reply. -3.18e+1. In the year 1998, what is the difference between the Taxes (in constant 2015 US$) of Armenia and Taxes (in constant 2015 US$) of Jamaica?
Make the answer very short. -7.54e+08. In the year 1998, what is the difference between the Taxes (in constant 2015 US$) of Armenia and Taxes (in constant 2015 US$) of Mexico?
Offer a terse response. -2.46e+1. In the year 1998, what is the difference between the Taxes (in constant 2015 US$) of India and Taxes (in constant 2015 US$) of Jamaica?
Your answer should be very brief. 3.11e+1. In the year 1998, what is the difference between the Taxes (in constant 2015 US$) of India and Taxes (in constant 2015 US$) of Mexico?
Ensure brevity in your answer.  7.27e+09. In the year 1998, what is the difference between the Taxes (in constant 2015 US$) in Jamaica and Taxes (in constant 2015 US$) in Mexico?
Ensure brevity in your answer.  -2.38e+1. In the year 1999, what is the difference between the Taxes (in constant 2015 US$) of Armenia and Taxes (in constant 2015 US$) of India?
Ensure brevity in your answer.  -3.79e+1. In the year 1999, what is the difference between the Taxes (in constant 2015 US$) in Armenia and Taxes (in constant 2015 US$) in Jamaica?
Make the answer very short. -8.04e+08. In the year 1999, what is the difference between the Taxes (in constant 2015 US$) in Armenia and Taxes (in constant 2015 US$) in Mexico?
Keep it short and to the point. -2.99e+1. In the year 1999, what is the difference between the Taxes (in constant 2015 US$) of India and Taxes (in constant 2015 US$) of Jamaica?
Offer a terse response. 3.71e+1. In the year 1999, what is the difference between the Taxes (in constant 2015 US$) in India and Taxes (in constant 2015 US$) in Mexico?
Your answer should be compact. 7.95e+09. In the year 1999, what is the difference between the Taxes (in constant 2015 US$) in Jamaica and Taxes (in constant 2015 US$) in Mexico?
Offer a very short reply. -2.91e+1. In the year 2000, what is the difference between the Taxes (in constant 2015 US$) of Armenia and Taxes (in constant 2015 US$) of India?
Offer a very short reply. -3.85e+1. In the year 2000, what is the difference between the Taxes (in constant 2015 US$) in Armenia and Taxes (in constant 2015 US$) in Jamaica?
Provide a succinct answer. -7.99e+08. In the year 2000, what is the difference between the Taxes (in constant 2015 US$) in Armenia and Taxes (in constant 2015 US$) in Mexico?
Your response must be concise. -3.27e+1. In the year 2000, what is the difference between the Taxes (in constant 2015 US$) in India and Taxes (in constant 2015 US$) in Jamaica?
Provide a succinct answer. 3.77e+1. In the year 2000, what is the difference between the Taxes (in constant 2015 US$) of India and Taxes (in constant 2015 US$) of Mexico?
Make the answer very short. 5.77e+09. In the year 2000, what is the difference between the Taxes (in constant 2015 US$) of Jamaica and Taxes (in constant 2015 US$) of Mexico?
Provide a succinct answer. -3.19e+1. In the year 2001, what is the difference between the Taxes (in constant 2015 US$) in Armenia and Taxes (in constant 2015 US$) in India?
Make the answer very short. -3.77e+1. In the year 2001, what is the difference between the Taxes (in constant 2015 US$) in Armenia and Taxes (in constant 2015 US$) in Jamaica?
Give a very brief answer. -7.96e+08. In the year 2001, what is the difference between the Taxes (in constant 2015 US$) in Armenia and Taxes (in constant 2015 US$) in Mexico?
Ensure brevity in your answer.  -3.71e+1. In the year 2001, what is the difference between the Taxes (in constant 2015 US$) in India and Taxes (in constant 2015 US$) in Jamaica?
Make the answer very short. 3.69e+1. In the year 2001, what is the difference between the Taxes (in constant 2015 US$) in India and Taxes (in constant 2015 US$) in Mexico?
Ensure brevity in your answer.  6.06e+08. In the year 2001, what is the difference between the Taxes (in constant 2015 US$) of Jamaica and Taxes (in constant 2015 US$) of Mexico?
Provide a short and direct response. -3.63e+1. In the year 2002, what is the difference between the Taxes (in constant 2015 US$) in Armenia and Taxes (in constant 2015 US$) in India?
Keep it short and to the point. -3.95e+1. In the year 2002, what is the difference between the Taxes (in constant 2015 US$) of Armenia and Taxes (in constant 2015 US$) of Jamaica?
Keep it short and to the point. -8.73e+08. In the year 2002, what is the difference between the Taxes (in constant 2015 US$) in Armenia and Taxes (in constant 2015 US$) in Mexico?
Offer a very short reply. -3.93e+1. In the year 2002, what is the difference between the Taxes (in constant 2015 US$) of India and Taxes (in constant 2015 US$) of Jamaica?
Offer a very short reply. 3.87e+1. In the year 2002, what is the difference between the Taxes (in constant 2015 US$) of India and Taxes (in constant 2015 US$) of Mexico?
Provide a succinct answer. 2.48e+08. In the year 2002, what is the difference between the Taxes (in constant 2015 US$) in Jamaica and Taxes (in constant 2015 US$) in Mexico?
Your answer should be very brief. -3.84e+1. What is the ratio of the Taxes (in constant 2015 US$) of Armenia in 1996 to that in 1997?
Keep it short and to the point. 0.67. What is the ratio of the Taxes (in constant 2015 US$) of India in 1996 to that in 1997?
Give a very brief answer. 0.99. What is the ratio of the Taxes (in constant 2015 US$) of Jamaica in 1996 to that in 1997?
Keep it short and to the point. 0.89. What is the ratio of the Taxes (in constant 2015 US$) in Mexico in 1996 to that in 1997?
Your answer should be very brief. 0.75. What is the ratio of the Taxes (in constant 2015 US$) of Armenia in 1996 to that in 1998?
Provide a short and direct response. 0.5. What is the ratio of the Taxes (in constant 2015 US$) in India in 1996 to that in 1998?
Offer a very short reply. 1.03. What is the ratio of the Taxes (in constant 2015 US$) of Jamaica in 1996 to that in 1998?
Offer a terse response. 0.49. What is the ratio of the Taxes (in constant 2015 US$) in Mexico in 1996 to that in 1998?
Your response must be concise. 0.64. What is the ratio of the Taxes (in constant 2015 US$) in Armenia in 1996 to that in 1999?
Offer a terse response. 0.56. What is the ratio of the Taxes (in constant 2015 US$) in India in 1996 to that in 1999?
Provide a succinct answer. 0.87. What is the ratio of the Taxes (in constant 2015 US$) in Jamaica in 1996 to that in 1999?
Give a very brief answer. 0.48. What is the ratio of the Taxes (in constant 2015 US$) of Mexico in 1996 to that in 1999?
Make the answer very short. 0.53. What is the ratio of the Taxes (in constant 2015 US$) of Armenia in 1996 to that in 2000?
Give a very brief answer. 0.5. What is the ratio of the Taxes (in constant 2015 US$) of India in 1996 to that in 2000?
Provide a succinct answer. 0.86. What is the ratio of the Taxes (in constant 2015 US$) in Jamaica in 1996 to that in 2000?
Your response must be concise. 0.47. What is the ratio of the Taxes (in constant 2015 US$) in Mexico in 1996 to that in 2000?
Keep it short and to the point. 0.48. What is the ratio of the Taxes (in constant 2015 US$) of Armenia in 1996 to that in 2001?
Your response must be concise. 0.43. What is the ratio of the Taxes (in constant 2015 US$) of India in 1996 to that in 2001?
Give a very brief answer. 0.87. What is the ratio of the Taxes (in constant 2015 US$) of Jamaica in 1996 to that in 2001?
Offer a terse response. 0.46. What is the ratio of the Taxes (in constant 2015 US$) in Mexico in 1996 to that in 2001?
Keep it short and to the point. 0.43. What is the ratio of the Taxes (in constant 2015 US$) in Armenia in 1996 to that in 2002?
Give a very brief answer. 0.38. What is the ratio of the Taxes (in constant 2015 US$) in India in 1996 to that in 2002?
Give a very brief answer. 0.83. What is the ratio of the Taxes (in constant 2015 US$) of Jamaica in 1996 to that in 2002?
Keep it short and to the point. 0.41. What is the ratio of the Taxes (in constant 2015 US$) of Mexico in 1996 to that in 2002?
Give a very brief answer. 0.4. What is the ratio of the Taxes (in constant 2015 US$) of Armenia in 1997 to that in 1998?
Provide a succinct answer. 0.75. What is the ratio of the Taxes (in constant 2015 US$) of India in 1997 to that in 1998?
Make the answer very short. 1.05. What is the ratio of the Taxes (in constant 2015 US$) in Jamaica in 1997 to that in 1998?
Give a very brief answer. 0.55. What is the ratio of the Taxes (in constant 2015 US$) in Mexico in 1997 to that in 1998?
Your answer should be very brief. 0.85. What is the ratio of the Taxes (in constant 2015 US$) in Armenia in 1997 to that in 1999?
Offer a terse response. 0.84. What is the ratio of the Taxes (in constant 2015 US$) in India in 1997 to that in 1999?
Your answer should be very brief. 0.88. What is the ratio of the Taxes (in constant 2015 US$) in Jamaica in 1997 to that in 1999?
Give a very brief answer. 0.53. What is the ratio of the Taxes (in constant 2015 US$) of Mexico in 1997 to that in 1999?
Your answer should be very brief. 0.7. What is the ratio of the Taxes (in constant 2015 US$) in Armenia in 1997 to that in 2000?
Your answer should be very brief. 0.75. What is the ratio of the Taxes (in constant 2015 US$) in India in 1997 to that in 2000?
Make the answer very short. 0.87. What is the ratio of the Taxes (in constant 2015 US$) in Jamaica in 1997 to that in 2000?
Give a very brief answer. 0.53. What is the ratio of the Taxes (in constant 2015 US$) of Mexico in 1997 to that in 2000?
Give a very brief answer. 0.64. What is the ratio of the Taxes (in constant 2015 US$) of Armenia in 1997 to that in 2001?
Keep it short and to the point. 0.64. What is the ratio of the Taxes (in constant 2015 US$) in India in 1997 to that in 2001?
Your response must be concise. 0.89. What is the ratio of the Taxes (in constant 2015 US$) of Jamaica in 1997 to that in 2001?
Provide a succinct answer. 0.51. What is the ratio of the Taxes (in constant 2015 US$) of Mexico in 1997 to that in 2001?
Make the answer very short. 0.57. What is the ratio of the Taxes (in constant 2015 US$) of Armenia in 1997 to that in 2002?
Offer a very short reply. 0.57. What is the ratio of the Taxes (in constant 2015 US$) of India in 1997 to that in 2002?
Offer a terse response. 0.84. What is the ratio of the Taxes (in constant 2015 US$) in Jamaica in 1997 to that in 2002?
Keep it short and to the point. 0.46. What is the ratio of the Taxes (in constant 2015 US$) in Mexico in 1997 to that in 2002?
Your answer should be compact. 0.53. What is the ratio of the Taxes (in constant 2015 US$) of Armenia in 1998 to that in 1999?
Your answer should be very brief. 1.12. What is the ratio of the Taxes (in constant 2015 US$) in India in 1998 to that in 1999?
Offer a very short reply. 0.84. What is the ratio of the Taxes (in constant 2015 US$) in Jamaica in 1998 to that in 1999?
Provide a succinct answer. 0.97. What is the ratio of the Taxes (in constant 2015 US$) of Mexico in 1998 to that in 1999?
Give a very brief answer. 0.82. What is the ratio of the Taxes (in constant 2015 US$) of Armenia in 1998 to that in 2000?
Keep it short and to the point. 1. What is the ratio of the Taxes (in constant 2015 US$) in India in 1998 to that in 2000?
Give a very brief answer. 0.83. What is the ratio of the Taxes (in constant 2015 US$) of Jamaica in 1998 to that in 2000?
Ensure brevity in your answer.  0.95. What is the ratio of the Taxes (in constant 2015 US$) of Mexico in 1998 to that in 2000?
Keep it short and to the point. 0.75. What is the ratio of the Taxes (in constant 2015 US$) in Armenia in 1998 to that in 2001?
Provide a succinct answer. 0.86. What is the ratio of the Taxes (in constant 2015 US$) in India in 1998 to that in 2001?
Keep it short and to the point. 0.85. What is the ratio of the Taxes (in constant 2015 US$) in Jamaica in 1998 to that in 2001?
Offer a very short reply. 0.93. What is the ratio of the Taxes (in constant 2015 US$) in Mexico in 1998 to that in 2001?
Ensure brevity in your answer.  0.66. What is the ratio of the Taxes (in constant 2015 US$) in Armenia in 1998 to that in 2002?
Ensure brevity in your answer.  0.76. What is the ratio of the Taxes (in constant 2015 US$) in India in 1998 to that in 2002?
Your answer should be compact. 0.81. What is the ratio of the Taxes (in constant 2015 US$) in Jamaica in 1998 to that in 2002?
Ensure brevity in your answer.  0.84. What is the ratio of the Taxes (in constant 2015 US$) in Mexico in 1998 to that in 2002?
Your answer should be compact. 0.63. What is the ratio of the Taxes (in constant 2015 US$) of Armenia in 1999 to that in 2000?
Provide a succinct answer. 0.9. What is the ratio of the Taxes (in constant 2015 US$) of India in 1999 to that in 2000?
Make the answer very short. 0.98. What is the ratio of the Taxes (in constant 2015 US$) in Jamaica in 1999 to that in 2000?
Provide a short and direct response. 0.99. What is the ratio of the Taxes (in constant 2015 US$) of Mexico in 1999 to that in 2000?
Your response must be concise. 0.92. What is the ratio of the Taxes (in constant 2015 US$) in Armenia in 1999 to that in 2001?
Ensure brevity in your answer.  0.77. What is the ratio of the Taxes (in constant 2015 US$) of India in 1999 to that in 2001?
Your answer should be very brief. 1.01. What is the ratio of the Taxes (in constant 2015 US$) of Jamaica in 1999 to that in 2001?
Give a very brief answer. 0.96. What is the ratio of the Taxes (in constant 2015 US$) in Mexico in 1999 to that in 2001?
Keep it short and to the point. 0.81. What is the ratio of the Taxes (in constant 2015 US$) in Armenia in 1999 to that in 2002?
Offer a very short reply. 0.68. What is the ratio of the Taxes (in constant 2015 US$) of India in 1999 to that in 2002?
Your answer should be compact. 0.96. What is the ratio of the Taxes (in constant 2015 US$) in Jamaica in 1999 to that in 2002?
Give a very brief answer. 0.87. What is the ratio of the Taxes (in constant 2015 US$) of Mexico in 1999 to that in 2002?
Your answer should be very brief. 0.76. What is the ratio of the Taxes (in constant 2015 US$) of Armenia in 2000 to that in 2001?
Your response must be concise. 0.85. What is the ratio of the Taxes (in constant 2015 US$) of India in 2000 to that in 2001?
Your answer should be very brief. 1.02. What is the ratio of the Taxes (in constant 2015 US$) of Jamaica in 2000 to that in 2001?
Keep it short and to the point. 0.97. What is the ratio of the Taxes (in constant 2015 US$) in Mexico in 2000 to that in 2001?
Your response must be concise. 0.88. What is the ratio of the Taxes (in constant 2015 US$) of Armenia in 2000 to that in 2002?
Provide a short and direct response. 0.76. What is the ratio of the Taxes (in constant 2015 US$) in India in 2000 to that in 2002?
Provide a succinct answer. 0.97. What is the ratio of the Taxes (in constant 2015 US$) of Jamaica in 2000 to that in 2002?
Keep it short and to the point. 0.88. What is the ratio of the Taxes (in constant 2015 US$) in Mexico in 2000 to that in 2002?
Your response must be concise. 0.83. What is the ratio of the Taxes (in constant 2015 US$) of Armenia in 2001 to that in 2002?
Keep it short and to the point. 0.89. What is the ratio of the Taxes (in constant 2015 US$) of India in 2001 to that in 2002?
Give a very brief answer. 0.95. What is the ratio of the Taxes (in constant 2015 US$) in Jamaica in 2001 to that in 2002?
Give a very brief answer. 0.91. What is the ratio of the Taxes (in constant 2015 US$) in Mexico in 2001 to that in 2002?
Your answer should be very brief. 0.94. What is the difference between the highest and the second highest Taxes (in constant 2015 US$) in Armenia?
Your response must be concise. 2.52e+07. What is the difference between the highest and the second highest Taxes (in constant 2015 US$) of India?
Provide a succinct answer. 1.09e+09. What is the difference between the highest and the second highest Taxes (in constant 2015 US$) of Jamaica?
Ensure brevity in your answer.  1.02e+08. What is the difference between the highest and the second highest Taxes (in constant 2015 US$) in Mexico?
Offer a very short reply. 2.26e+09. What is the difference between the highest and the lowest Taxes (in constant 2015 US$) of Armenia?
Offer a very short reply. 1.42e+08. What is the difference between the highest and the lowest Taxes (in constant 2015 US$) in India?
Offer a very short reply. 7.75e+09. What is the difference between the highest and the lowest Taxes (in constant 2015 US$) of Jamaica?
Give a very brief answer. 6.46e+08. What is the difference between the highest and the lowest Taxes (in constant 2015 US$) in Mexico?
Provide a short and direct response. 2.37e+1. 